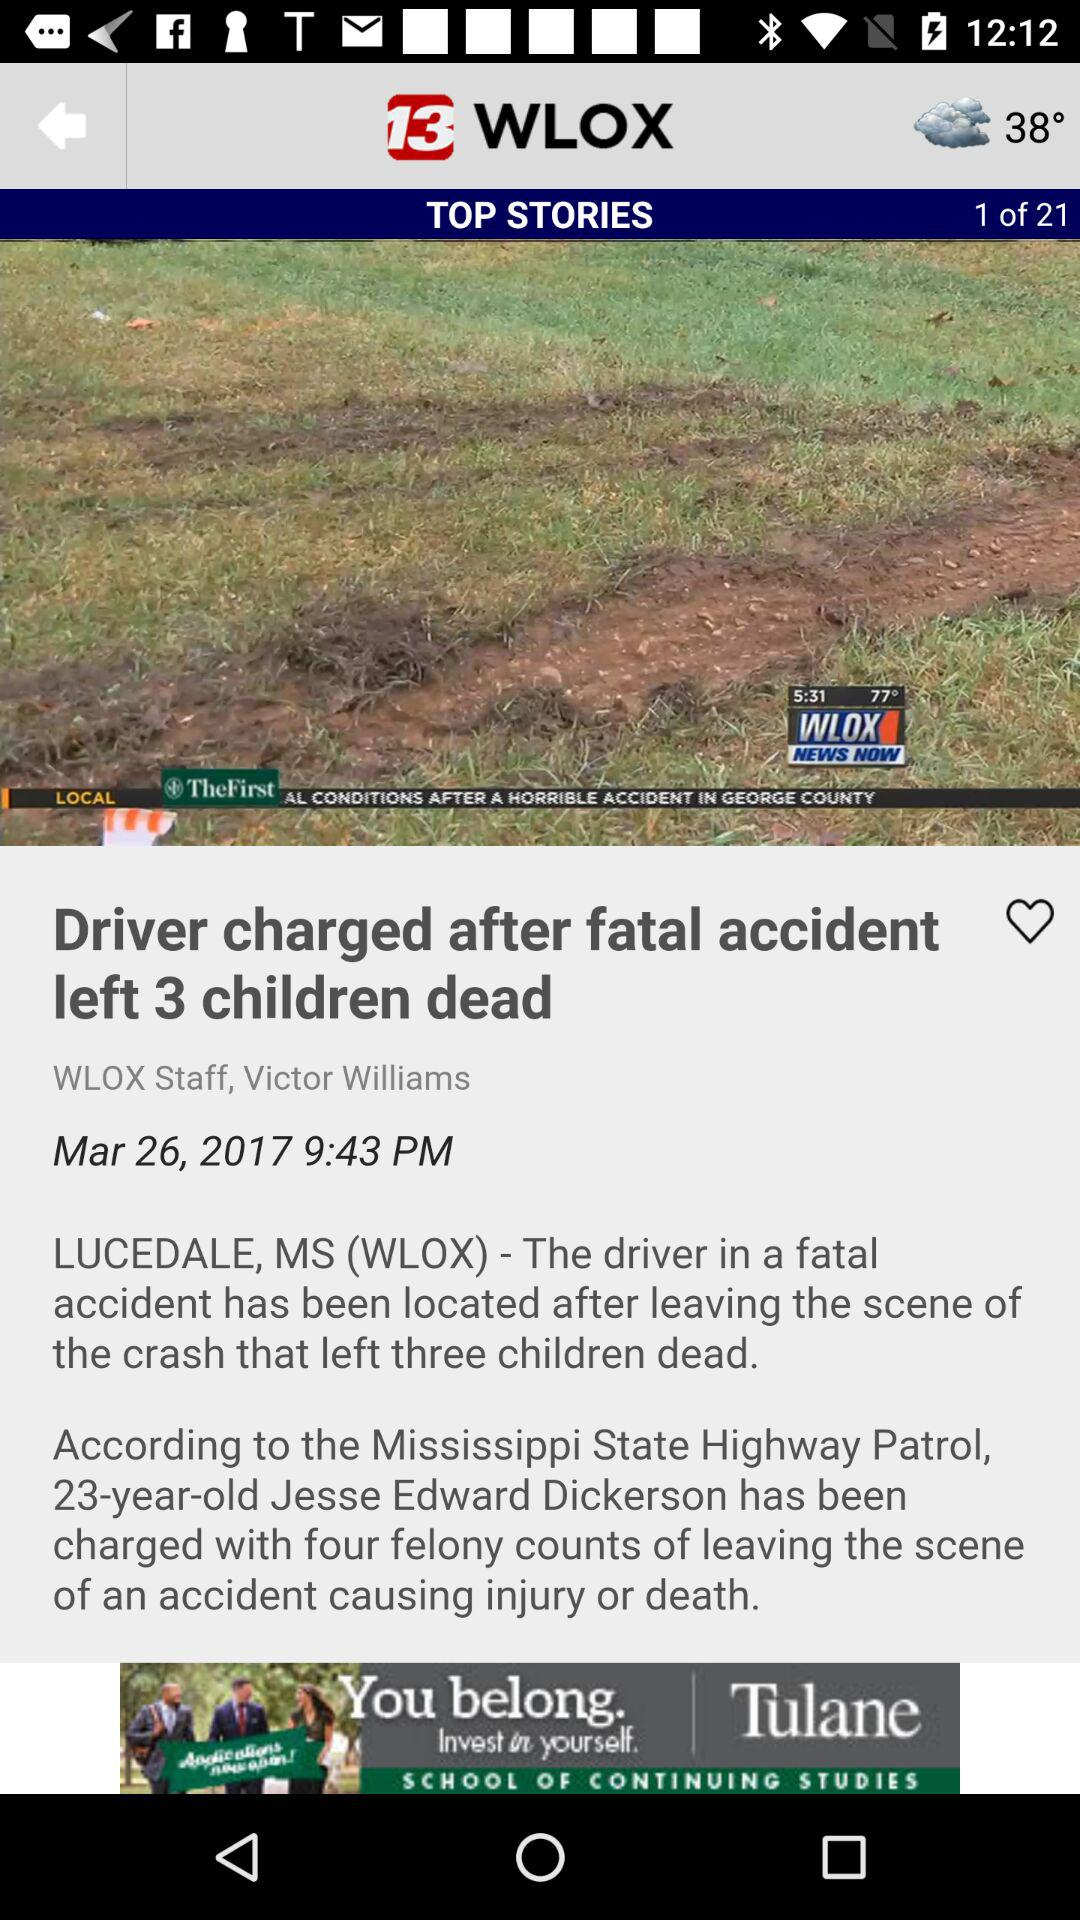Who's the author of the news article? The author of the news article is Victor Williams. 